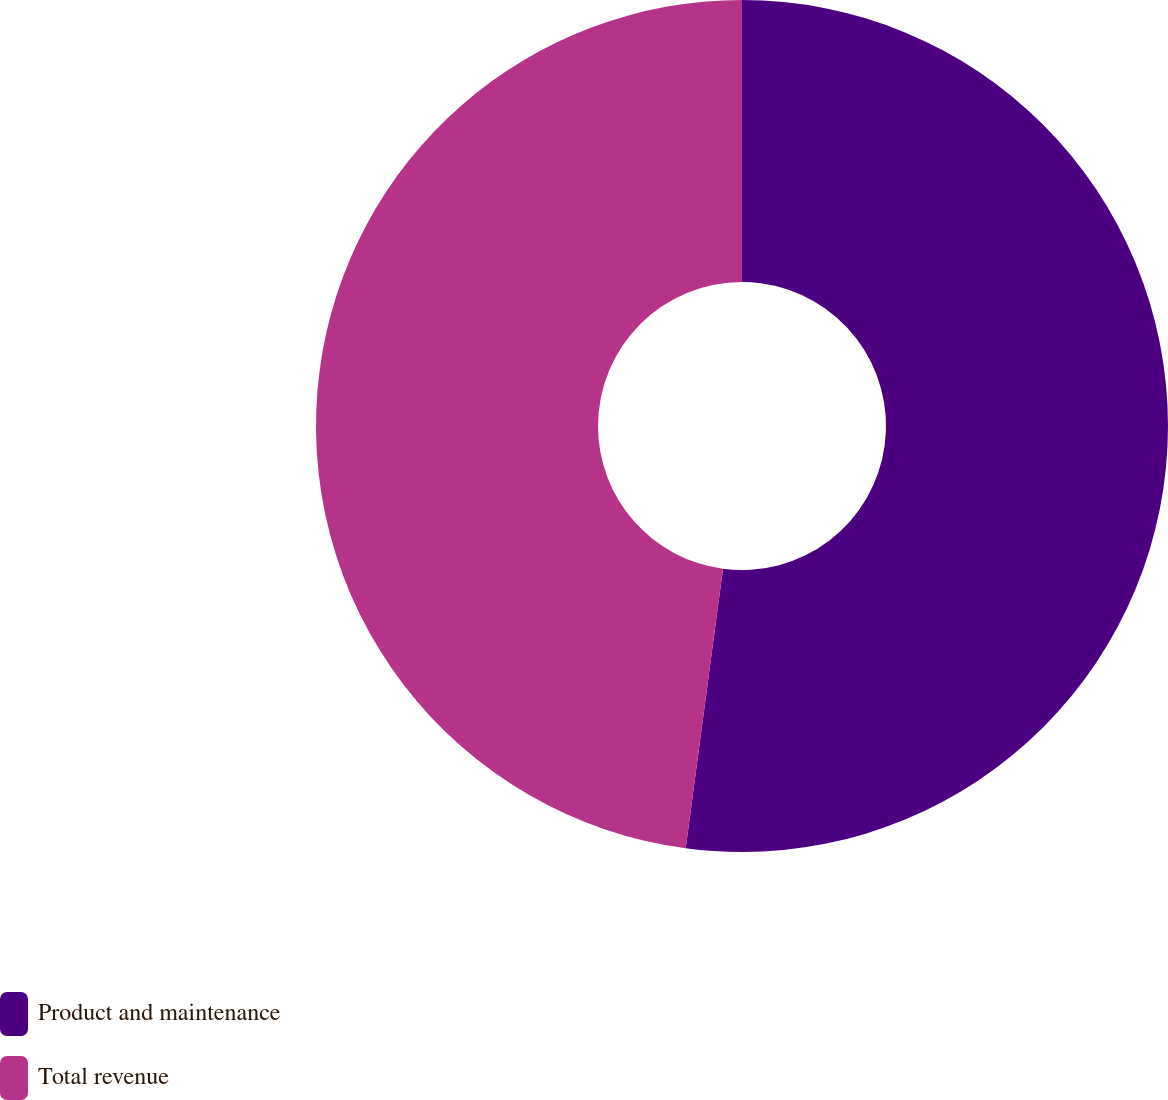Convert chart. <chart><loc_0><loc_0><loc_500><loc_500><pie_chart><fcel>Product and maintenance<fcel>Total revenue<nl><fcel>52.11%<fcel>47.89%<nl></chart> 